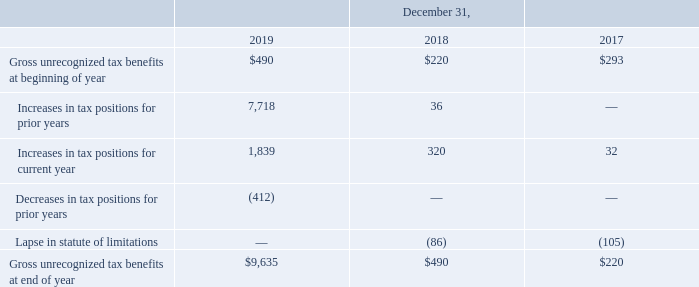A reconciliation of the beginning and ending balances of the total amounts of gross unrecognized tax benefits is as follows (in thousands):
The total liability for gross unrecognized tax benefits as of December 31, 2019, 2018 and 2017 includes $9.6 million, $0.4 million and $0.2 million, respectively, of unrecognized net tax benefits which, if ultimately recognized, would reduce our annual effective tax rate in a future period. These liabilities, along with liabilities for interest and penalties, are included in accounts payable and accrued expenses and Other long-term liabilities in our consolidated balance sheet. Interest, which is included in Interest expense in our consolidated statement of income, was not material for all years presented.
During the year ended December 31, 2019, we recognized an increase in unrecognized tax benefits of approximately $7.7 million related to an increase in research and development tax credits available to us for tax years 2016-2018 and $1.8 million for the 2019 tax year.
We are subject to income taxes in the U.S., various state and foreign jurisdictions. Tax statutes and regulations within each jurisdiction are subject to interpretation and require significant judgment to apply. We are no longer subject to U.S. federal or non-U.S. income tax examinations by tax authorities for the years before 2015. We are no longer subject to U.S. state tax examinations by tax authorities for the years before 2014. We believe it is reasonably possible that within the next year our unrecognized tax benefits may decrease by $1.9 million due to the acceptance of a portion of our amended research and development credits.
What does the table show us? A reconciliation of the beginning and ending balances of the total amounts of gross unrecognized tax benefits. The company believes that it is possible that within the next year, unrecognized tax benefits may decrease by $1.9 million. What causes that decrease? The acceptance of a portion of our amended research and development credits. What did the increase of approximately $7.7 million in unrecognized tax benefits relate to, during the year ended December 21, 2019? An increase in research and development tax credits available to us for tax years 2016-2018 and $1.8 million for the 2019 tax year. What is the percentage change of gross unrecognized tax benefits from the end of the year 2017 to 2018?
Answer scale should be: percent. ($490-$220)/$220 
Answer: 122.73. What is the proportion of the total increase in tax positions for the prior and current years over gross unrecognized tax benefits at the end of the year 2019? (7,718+1,839)/9,635
Answer: 0.99. What is the total lapse in the statute of limitations from 2017 to 2019?
Answer scale should be: thousand. -105+(-86)+0
Answer: -191. 